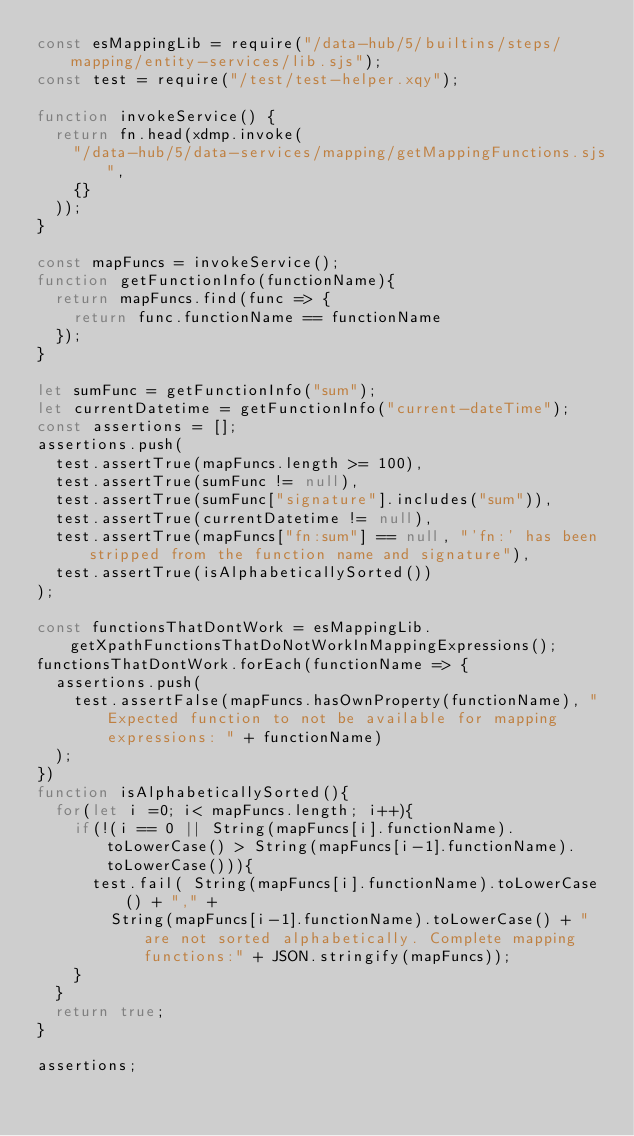<code> <loc_0><loc_0><loc_500><loc_500><_JavaScript_>const esMappingLib = require("/data-hub/5/builtins/steps/mapping/entity-services/lib.sjs");
const test = require("/test/test-helper.xqy");

function invokeService() {
  return fn.head(xdmp.invoke(
    "/data-hub/5/data-services/mapping/getMappingFunctions.sjs",
    {}
  ));
}

const mapFuncs = invokeService();
function getFunctionInfo(functionName){
  return mapFuncs.find(func => {
    return func.functionName == functionName
  });
}

let sumFunc = getFunctionInfo("sum");
let currentDatetime = getFunctionInfo("current-dateTime");
const assertions = [];
assertions.push(
  test.assertTrue(mapFuncs.length >= 100),
  test.assertTrue(sumFunc != null),
  test.assertTrue(sumFunc["signature"].includes("sum")),
  test.assertTrue(currentDatetime != null),
  test.assertTrue(mapFuncs["fn:sum"] == null, "'fn:' has been stripped from the function name and signature"),
  test.assertTrue(isAlphabeticallySorted())
);

const functionsThatDontWork = esMappingLib.getXpathFunctionsThatDoNotWorkInMappingExpressions();
functionsThatDontWork.forEach(functionName => {
  assertions.push(
    test.assertFalse(mapFuncs.hasOwnProperty(functionName), "Expected function to not be available for mapping expressions: " + functionName)
  );
})
function isAlphabeticallySorted(){
  for(let i =0; i< mapFuncs.length; i++){
    if(!(i == 0 || String(mapFuncs[i].functionName).toLowerCase() > String(mapFuncs[i-1].functionName).toLowerCase())){
      test.fail( String(mapFuncs[i].functionName).toLowerCase() + "," +
        String(mapFuncs[i-1].functionName).toLowerCase() + " are not sorted alphabetically. Complete mapping functions:" + JSON.stringify(mapFuncs));
    }
  }
  return true;
}

assertions;

</code> 